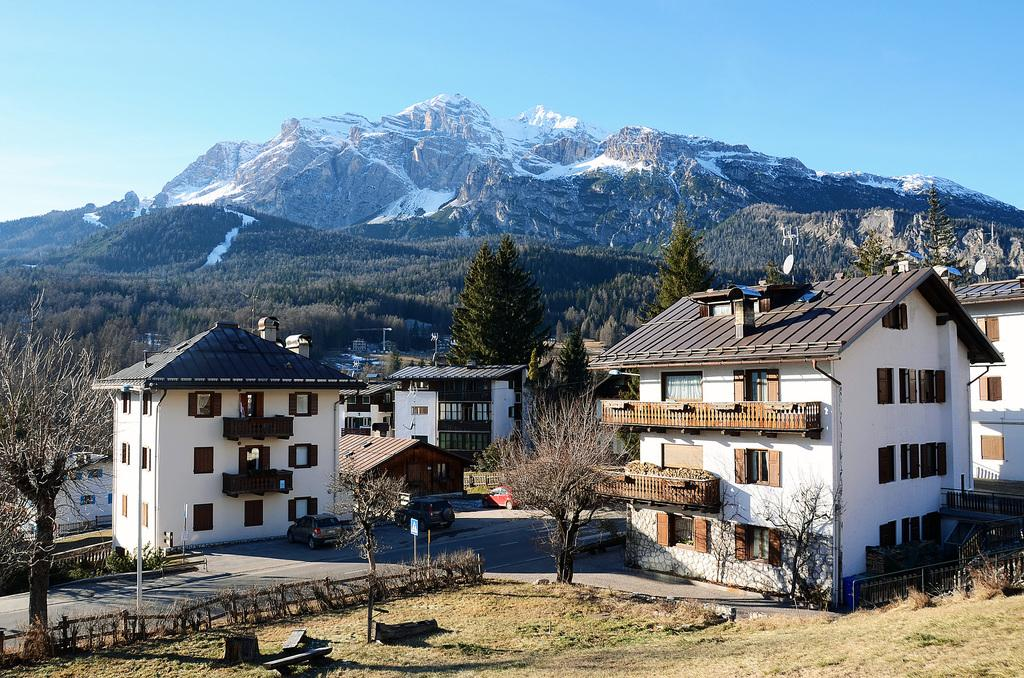What type of structures can be seen in the image? There are buildings in the image. What other natural elements are present in the image? There are trees in the image. What can be seen in the distance in the image? There are mountains in the background of the image. What is visible in the sky in the image? The sky is visible in the background of the image. How does the comparison between jeans and the image help us understand the scene better? There is no mention of jeans in the image, so a comparison between jeans and the image is not relevant or possible. 